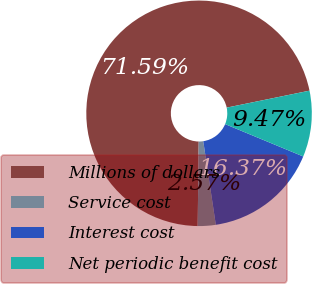Convert chart to OTSL. <chart><loc_0><loc_0><loc_500><loc_500><pie_chart><fcel>Millions of dollars<fcel>Service cost<fcel>Interest cost<fcel>Net periodic benefit cost<nl><fcel>71.58%<fcel>2.57%<fcel>16.37%<fcel>9.47%<nl></chart> 